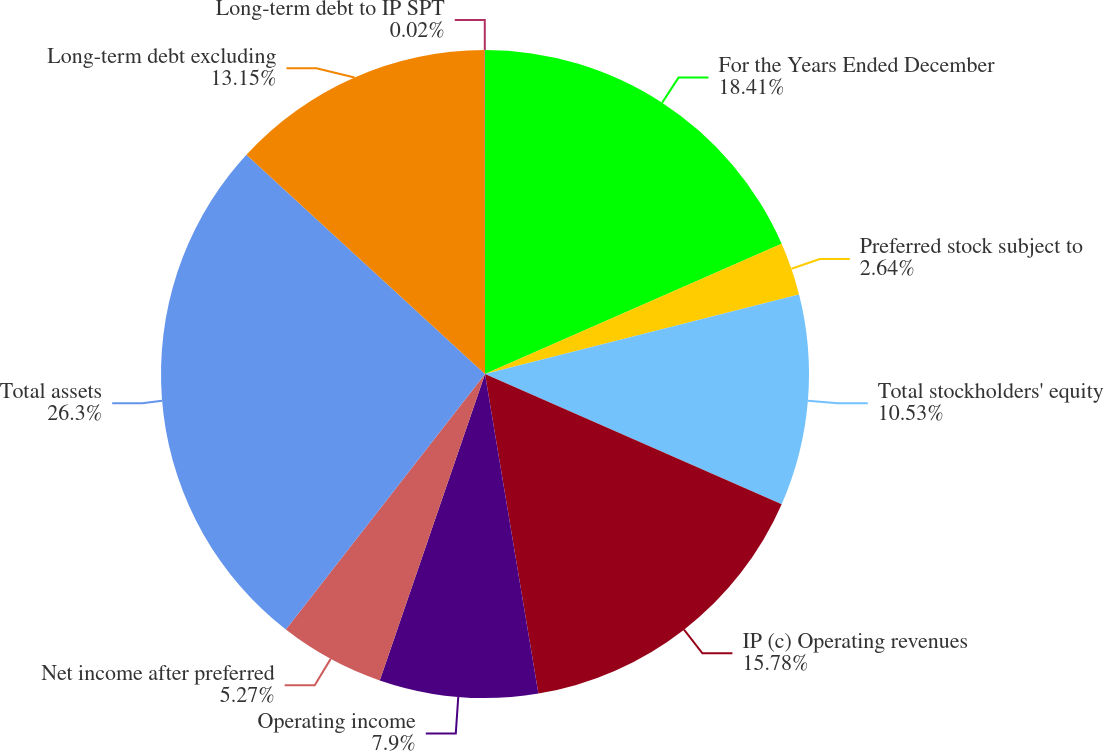<chart> <loc_0><loc_0><loc_500><loc_500><pie_chart><fcel>For the Years Ended December<fcel>Preferred stock subject to<fcel>Total stockholders' equity<fcel>IP (c) Operating revenues<fcel>Operating income<fcel>Net income after preferred<fcel>Total assets<fcel>Long-term debt excluding<fcel>Long-term debt to IP SPT<nl><fcel>18.41%<fcel>2.64%<fcel>10.53%<fcel>15.78%<fcel>7.9%<fcel>5.27%<fcel>26.29%<fcel>13.15%<fcel>0.02%<nl></chart> 